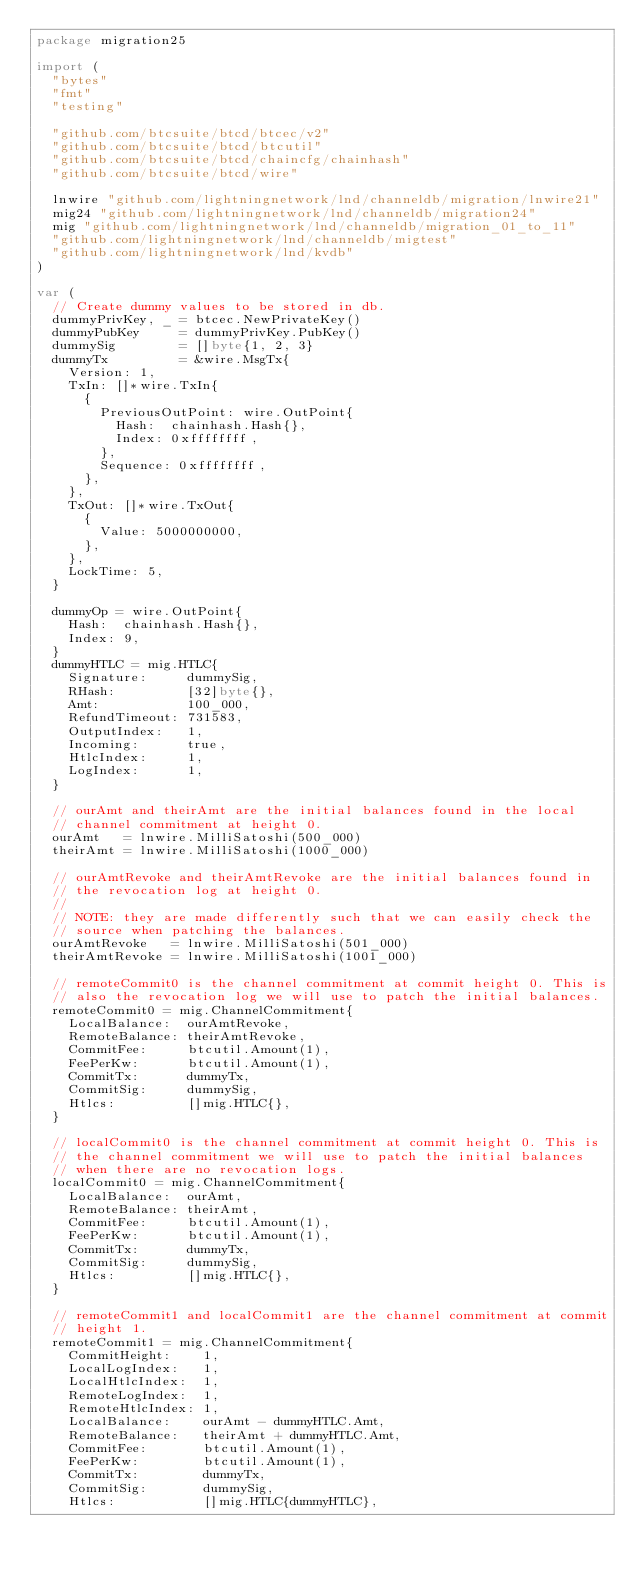Convert code to text. <code><loc_0><loc_0><loc_500><loc_500><_Go_>package migration25

import (
	"bytes"
	"fmt"
	"testing"

	"github.com/btcsuite/btcd/btcec/v2"
	"github.com/btcsuite/btcd/btcutil"
	"github.com/btcsuite/btcd/chaincfg/chainhash"
	"github.com/btcsuite/btcd/wire"

	lnwire "github.com/lightningnetwork/lnd/channeldb/migration/lnwire21"
	mig24 "github.com/lightningnetwork/lnd/channeldb/migration24"
	mig "github.com/lightningnetwork/lnd/channeldb/migration_01_to_11"
	"github.com/lightningnetwork/lnd/channeldb/migtest"
	"github.com/lightningnetwork/lnd/kvdb"
)

var (
	// Create dummy values to be stored in db.
	dummyPrivKey, _ = btcec.NewPrivateKey()
	dummyPubKey     = dummyPrivKey.PubKey()
	dummySig        = []byte{1, 2, 3}
	dummyTx         = &wire.MsgTx{
		Version: 1,
		TxIn: []*wire.TxIn{
			{
				PreviousOutPoint: wire.OutPoint{
					Hash:  chainhash.Hash{},
					Index: 0xffffffff,
				},
				Sequence: 0xffffffff,
			},
		},
		TxOut: []*wire.TxOut{
			{
				Value: 5000000000,
			},
		},
		LockTime: 5,
	}

	dummyOp = wire.OutPoint{
		Hash:  chainhash.Hash{},
		Index: 9,
	}
	dummyHTLC = mig.HTLC{
		Signature:     dummySig,
		RHash:         [32]byte{},
		Amt:           100_000,
		RefundTimeout: 731583,
		OutputIndex:   1,
		Incoming:      true,
		HtlcIndex:     1,
		LogIndex:      1,
	}

	// ourAmt and theirAmt are the initial balances found in the local
	// channel commitment at height 0.
	ourAmt   = lnwire.MilliSatoshi(500_000)
	theirAmt = lnwire.MilliSatoshi(1000_000)

	// ourAmtRevoke and theirAmtRevoke are the initial balances found in
	// the revocation log at height 0.
	//
	// NOTE: they are made differently such that we can easily check the
	// source when patching the balances.
	ourAmtRevoke   = lnwire.MilliSatoshi(501_000)
	theirAmtRevoke = lnwire.MilliSatoshi(1001_000)

	// remoteCommit0 is the channel commitment at commit height 0. This is
	// also the revocation log we will use to patch the initial balances.
	remoteCommit0 = mig.ChannelCommitment{
		LocalBalance:  ourAmtRevoke,
		RemoteBalance: theirAmtRevoke,
		CommitFee:     btcutil.Amount(1),
		FeePerKw:      btcutil.Amount(1),
		CommitTx:      dummyTx,
		CommitSig:     dummySig,
		Htlcs:         []mig.HTLC{},
	}

	// localCommit0 is the channel commitment at commit height 0. This is
	// the channel commitment we will use to patch the initial balances
	// when there are no revocation logs.
	localCommit0 = mig.ChannelCommitment{
		LocalBalance:  ourAmt,
		RemoteBalance: theirAmt,
		CommitFee:     btcutil.Amount(1),
		FeePerKw:      btcutil.Amount(1),
		CommitTx:      dummyTx,
		CommitSig:     dummySig,
		Htlcs:         []mig.HTLC{},
	}

	// remoteCommit1 and localCommit1 are the channel commitment at commit
	// height 1.
	remoteCommit1 = mig.ChannelCommitment{
		CommitHeight:    1,
		LocalLogIndex:   1,
		LocalHtlcIndex:  1,
		RemoteLogIndex:  1,
		RemoteHtlcIndex: 1,
		LocalBalance:    ourAmt - dummyHTLC.Amt,
		RemoteBalance:   theirAmt + dummyHTLC.Amt,
		CommitFee:       btcutil.Amount(1),
		FeePerKw:        btcutil.Amount(1),
		CommitTx:        dummyTx,
		CommitSig:       dummySig,
		Htlcs:           []mig.HTLC{dummyHTLC},</code> 